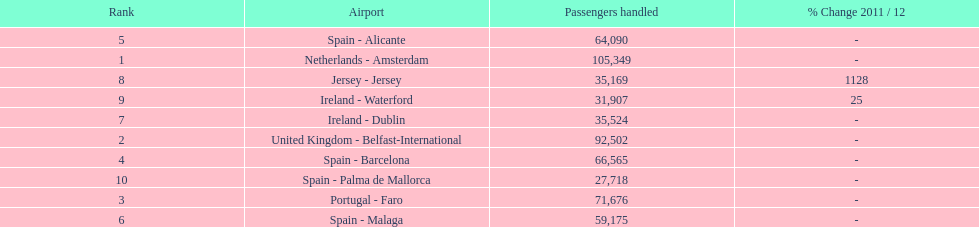Between the topped ranked airport, netherlands - amsterdam, & spain - palma de mallorca, what is the difference in the amount of passengers handled? 77,631. 